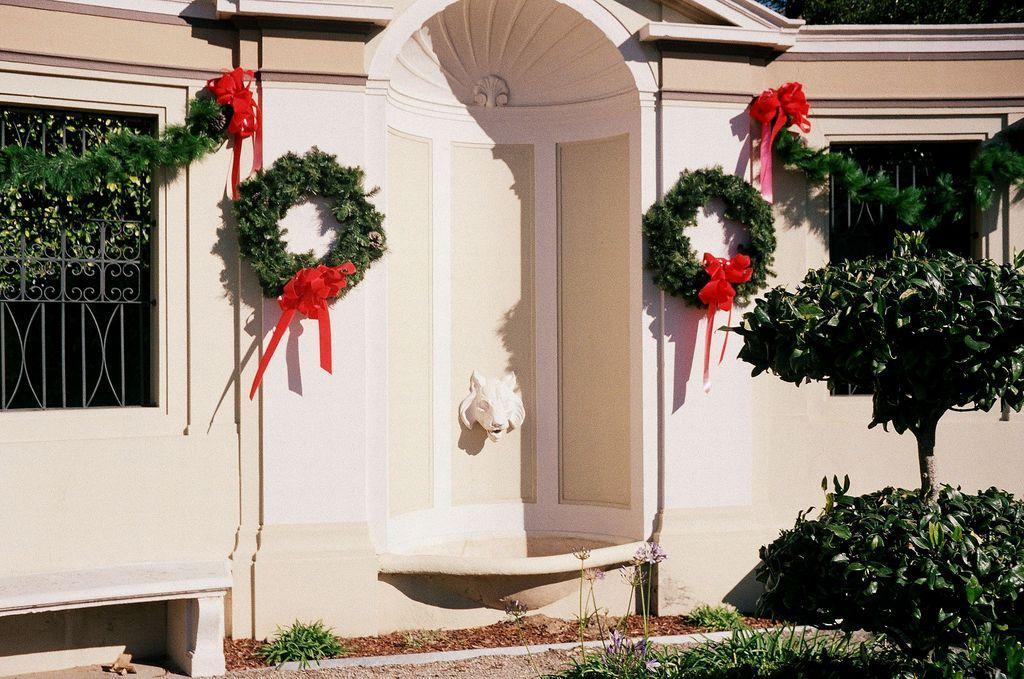Please provide a concise description of this image. In the picture we can see a house wall with two windows and some decorations on the wall and near it we can see some plants and grass surface. 